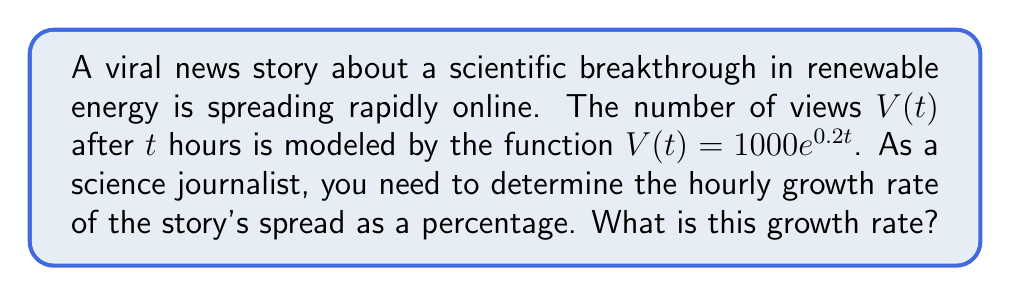Show me your answer to this math problem. To solve this problem, we'll follow these steps:

1) The general form of an exponential function is:
   $f(t) = ae^{rt}$
   where $r$ is the continuous growth rate.

2) In our case, $V(t) = 1000e^{0.2t}$, so $r = 0.2$.

3) However, this is the continuous growth rate, not the hourly growth rate as a percentage.

4) To convert the continuous growth rate to a percentage growth rate, we use the formula:
   $\text{Percentage Growth Rate} = (e^r - 1) \times 100\%$

5) Plugging in our $r$ value:
   $\text{Percentage Growth Rate} = (e^{0.2} - 1) \times 100\%$

6) Calculate:
   $e^{0.2} \approx 1.2214$
   $1.2214 - 1 = 0.2214$
   $0.2214 \times 100\% = 22.14\%$

Therefore, the hourly growth rate of the story's spread is approximately 22.14%.
Answer: 22.14% 